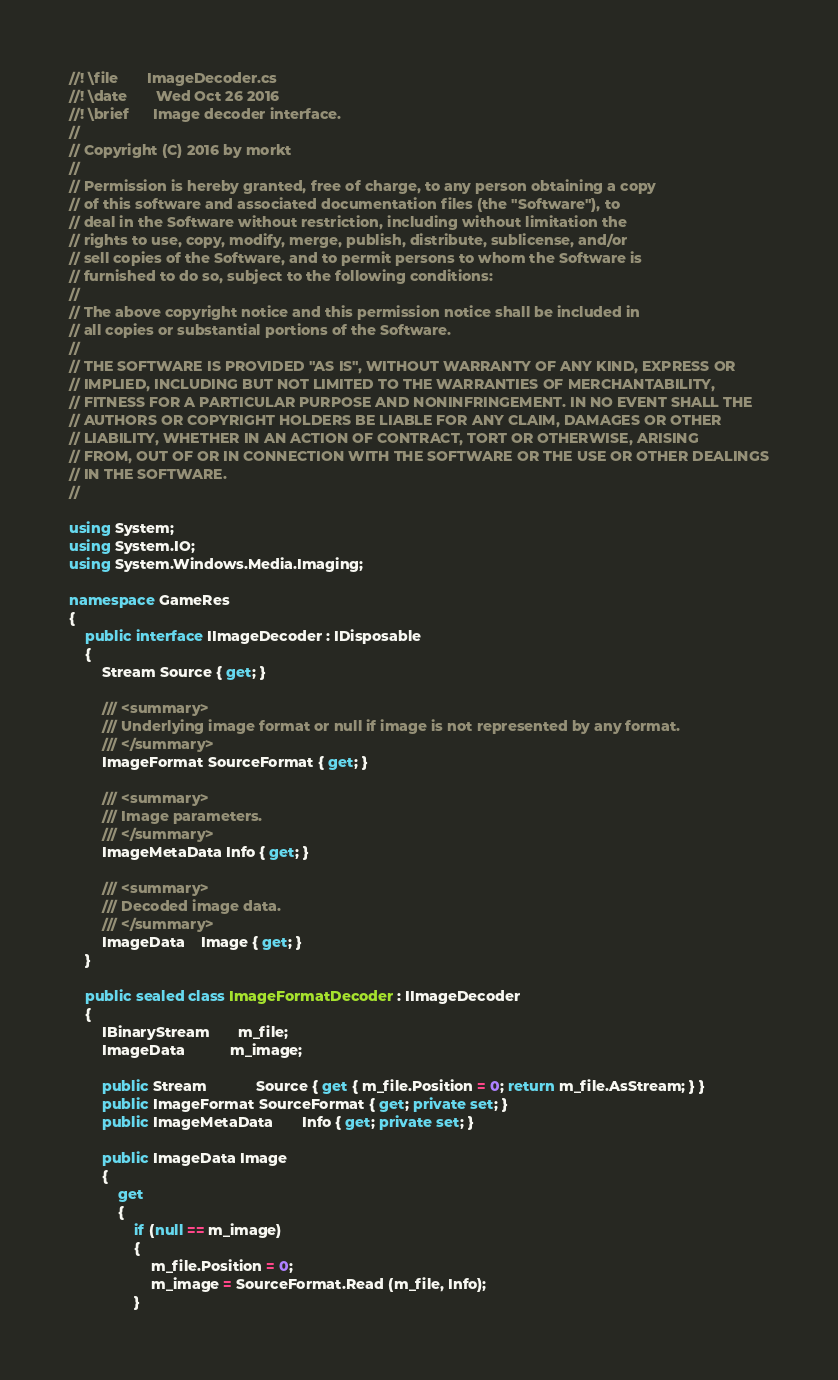<code> <loc_0><loc_0><loc_500><loc_500><_C#_>//! \file       ImageDecoder.cs
//! \date       Wed Oct 26 2016
//! \brief      Image decoder interface.
//
// Copyright (C) 2016 by morkt
//
// Permission is hereby granted, free of charge, to any person obtaining a copy
// of this software and associated documentation files (the "Software"), to
// deal in the Software without restriction, including without limitation the
// rights to use, copy, modify, merge, publish, distribute, sublicense, and/or
// sell copies of the Software, and to permit persons to whom the Software is
// furnished to do so, subject to the following conditions:
//
// The above copyright notice and this permission notice shall be included in
// all copies or substantial portions of the Software.
//
// THE SOFTWARE IS PROVIDED "AS IS", WITHOUT WARRANTY OF ANY KIND, EXPRESS OR
// IMPLIED, INCLUDING BUT NOT LIMITED TO THE WARRANTIES OF MERCHANTABILITY,
// FITNESS FOR A PARTICULAR PURPOSE AND NONINFRINGEMENT. IN NO EVENT SHALL THE
// AUTHORS OR COPYRIGHT HOLDERS BE LIABLE FOR ANY CLAIM, DAMAGES OR OTHER
// LIABILITY, WHETHER IN AN ACTION OF CONTRACT, TORT OR OTHERWISE, ARISING
// FROM, OUT OF OR IN CONNECTION WITH THE SOFTWARE OR THE USE OR OTHER DEALINGS
// IN THE SOFTWARE.
//

using System;
using System.IO;
using System.Windows.Media.Imaging;

namespace GameRes
{
    public interface IImageDecoder : IDisposable
    {
        Stream Source { get; }

        /// <summary>
        /// Underlying image format or null if image is not represented by any format.
        /// </summary>
        ImageFormat SourceFormat { get; }

        /// <summary>
        /// Image parameters.
        /// </summary>
        ImageMetaData Info { get; }

        /// <summary>
        /// Decoded image data.
        /// </summary>
        ImageData    Image { get; }
    }

    public sealed class ImageFormatDecoder : IImageDecoder
    {
        IBinaryStream       m_file;
        ImageData           m_image;

        public Stream            Source { get { m_file.Position = 0; return m_file.AsStream; } }
        public ImageFormat SourceFormat { get; private set; }
        public ImageMetaData       Info { get; private set; }

        public ImageData Image
        {
            get
            {
                if (null == m_image)
                {
                    m_file.Position = 0;
                    m_image = SourceFormat.Read (m_file, Info);
                }</code> 